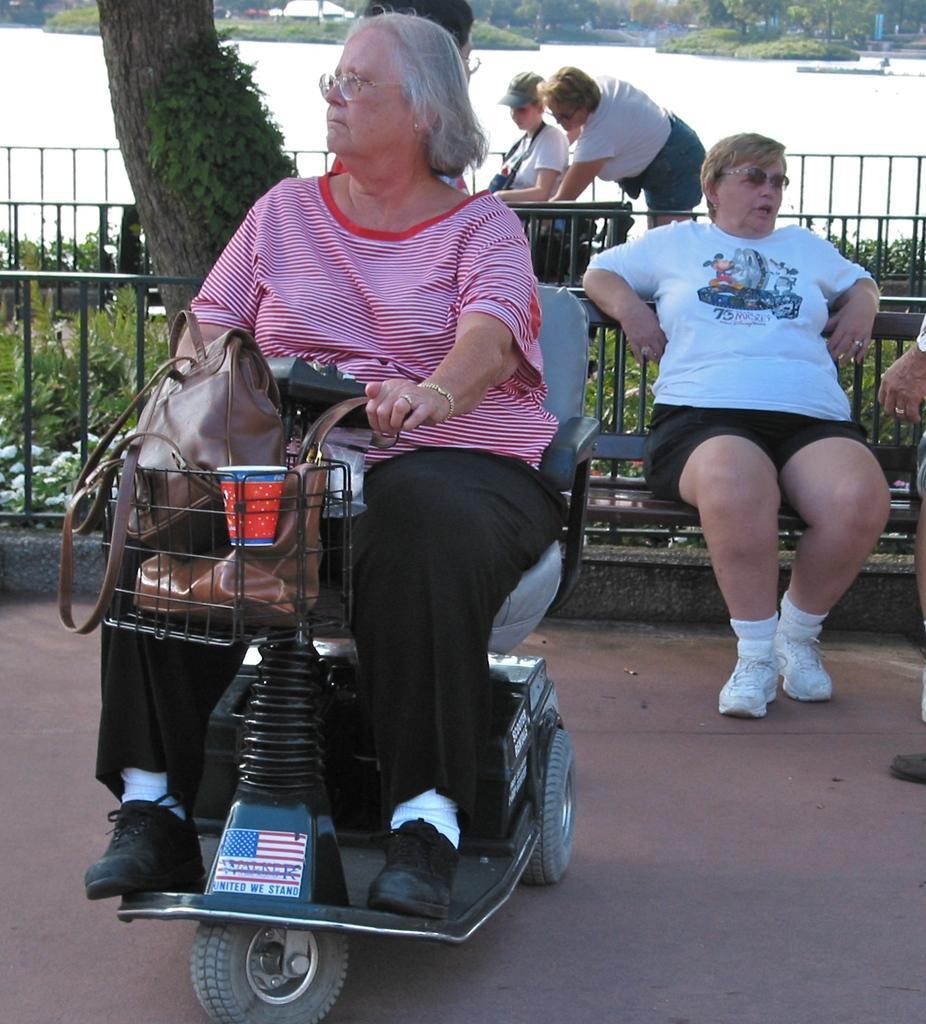Please provide a concise description of this image. In this image in the foreground there is one person sitting on a chair, and there are handbags and cup in the basket and in the background there is a trailing, plants and some people, trees, river, buildings and at the bottom there is walkway. 